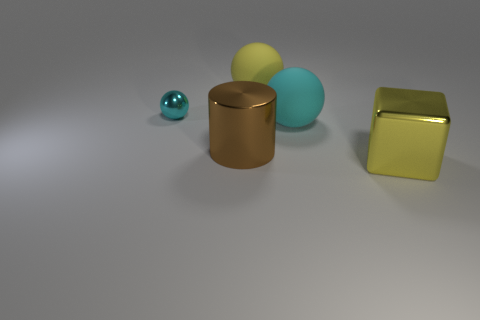Subtract all red cylinders. How many cyan balls are left? 2 Subtract all rubber balls. How many balls are left? 1 Add 1 large brown objects. How many objects exist? 6 Subtract 1 spheres. How many spheres are left? 2 Subtract all blocks. How many objects are left? 4 Add 5 green matte cylinders. How many green matte cylinders exist? 5 Subtract 1 brown cylinders. How many objects are left? 4 Subtract all large brown metallic things. Subtract all brown shiny objects. How many objects are left? 3 Add 3 yellow metal objects. How many yellow metal objects are left? 4 